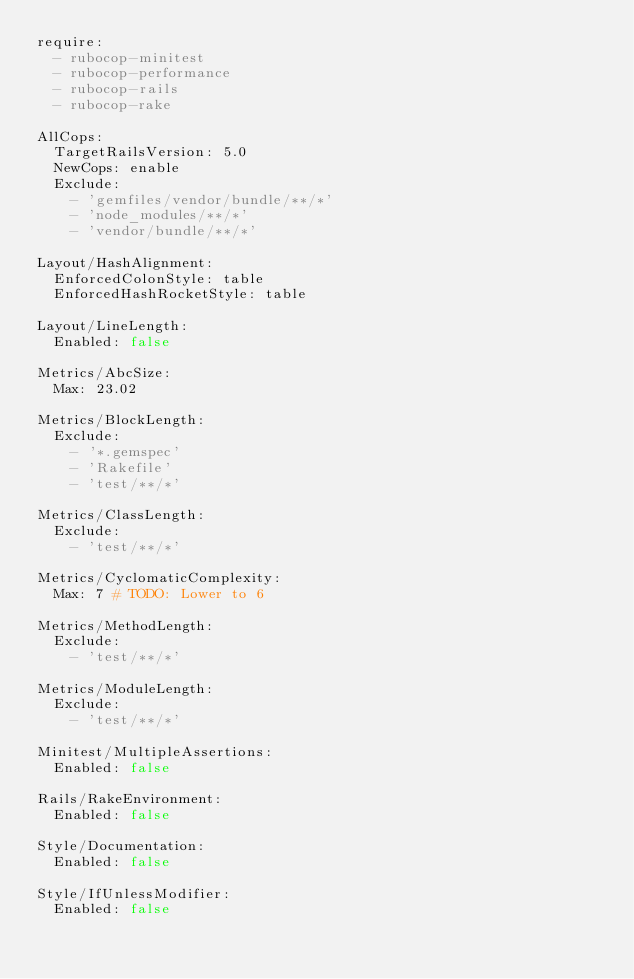<code> <loc_0><loc_0><loc_500><loc_500><_YAML_>require:
  - rubocop-minitest
  - rubocop-performance
  - rubocop-rails
  - rubocop-rake

AllCops:
  TargetRailsVersion: 5.0
  NewCops: enable
  Exclude:
    - 'gemfiles/vendor/bundle/**/*'
    - 'node_modules/**/*'
    - 'vendor/bundle/**/*'

Layout/HashAlignment:
  EnforcedColonStyle: table
  EnforcedHashRocketStyle: table

Layout/LineLength:
  Enabled: false

Metrics/AbcSize:
  Max: 23.02

Metrics/BlockLength:
  Exclude:
    - '*.gemspec'
    - 'Rakefile'
    - 'test/**/*'

Metrics/ClassLength:
  Exclude:
    - 'test/**/*'

Metrics/CyclomaticComplexity:
  Max: 7 # TODO: Lower to 6

Metrics/MethodLength:
  Exclude:
    - 'test/**/*'

Metrics/ModuleLength:
  Exclude:
    - 'test/**/*'

Minitest/MultipleAssertions:
  Enabled: false

Rails/RakeEnvironment:
  Enabled: false

Style/Documentation:
  Enabled: false

Style/IfUnlessModifier:
  Enabled: false
</code> 